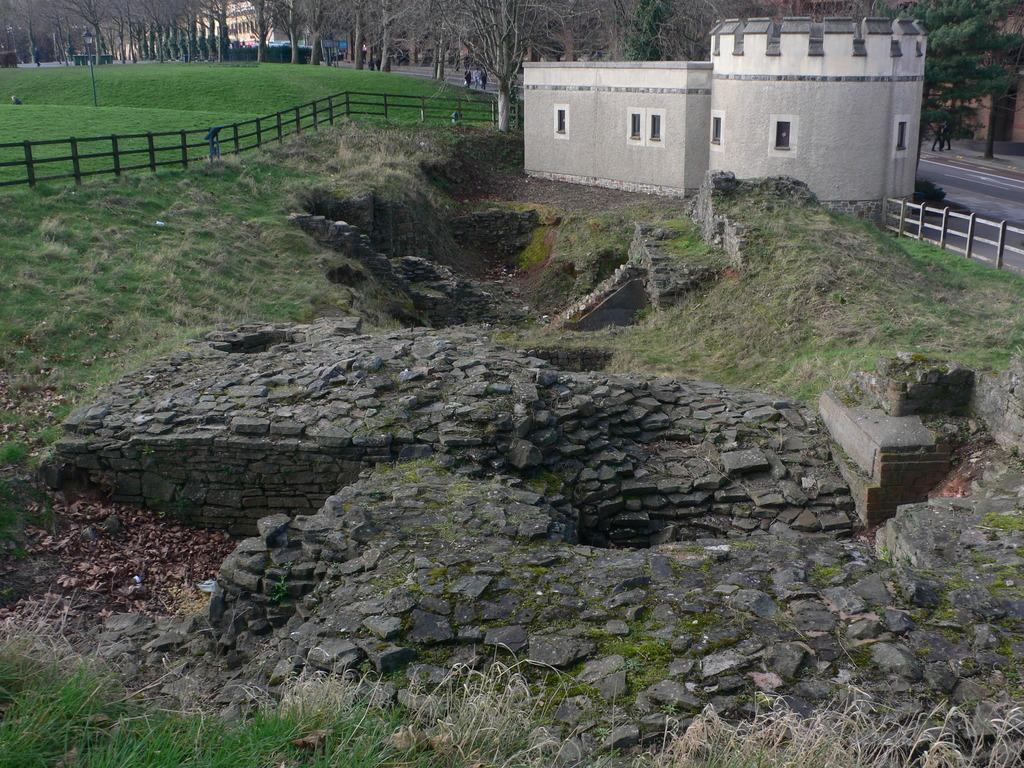What is located in the foreground of the image? There are stones and grassland in the foreground of the image. What can be seen in the background of the image? There are people, a boundary, trees, buildings, and grassland in the background of the image. Can you tell me how many snails are crawling on the rice in the image? There is no rice or snails present in the image. What type of beast is visible in the background of the image? There is no beast present in the image; the background features people, a boundary, trees, buildings, and grassland. 